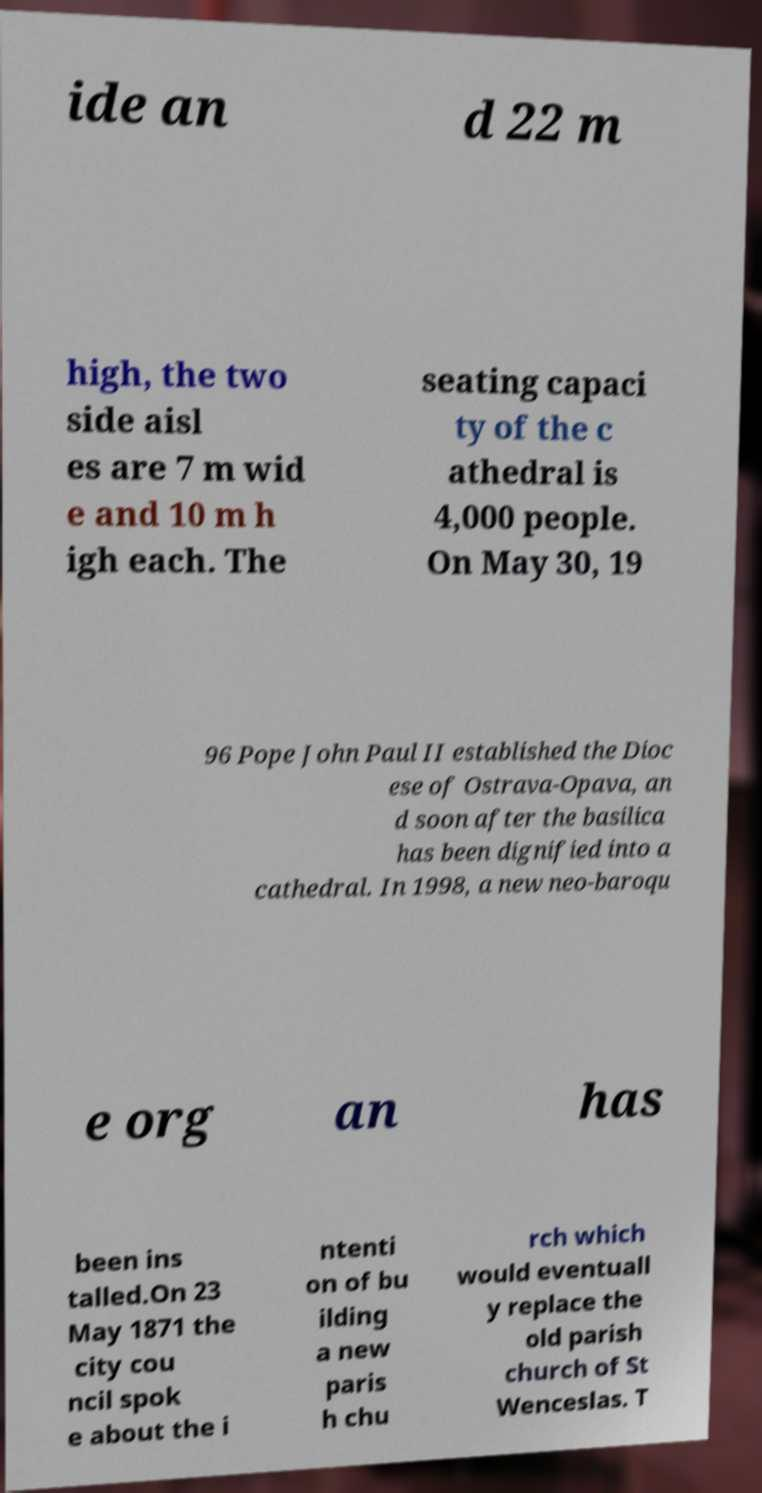Can you accurately transcribe the text from the provided image for me? ide an d 22 m high, the two side aisl es are 7 m wid e and 10 m h igh each. The seating capaci ty of the c athedral is 4,000 people. On May 30, 19 96 Pope John Paul II established the Dioc ese of Ostrava-Opava, an d soon after the basilica has been dignified into a cathedral. In 1998, a new neo-baroqu e org an has been ins talled.On 23 May 1871 the city cou ncil spok e about the i ntenti on of bu ilding a new paris h chu rch which would eventuall y replace the old parish church of St Wenceslas. T 